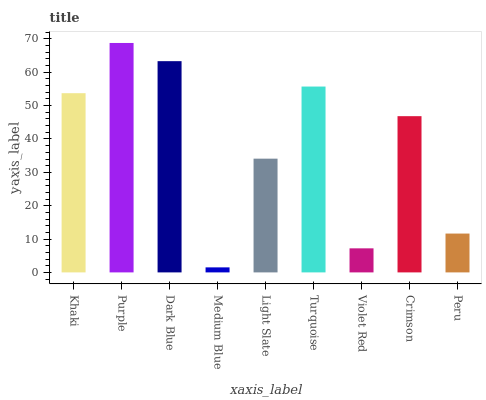Is Medium Blue the minimum?
Answer yes or no. Yes. Is Purple the maximum?
Answer yes or no. Yes. Is Dark Blue the minimum?
Answer yes or no. No. Is Dark Blue the maximum?
Answer yes or no. No. Is Purple greater than Dark Blue?
Answer yes or no. Yes. Is Dark Blue less than Purple?
Answer yes or no. Yes. Is Dark Blue greater than Purple?
Answer yes or no. No. Is Purple less than Dark Blue?
Answer yes or no. No. Is Crimson the high median?
Answer yes or no. Yes. Is Crimson the low median?
Answer yes or no. Yes. Is Turquoise the high median?
Answer yes or no. No. Is Peru the low median?
Answer yes or no. No. 